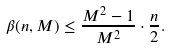Convert formula to latex. <formula><loc_0><loc_0><loc_500><loc_500>\beta ( n , M ) \leq \frac { M ^ { 2 } - 1 } { M ^ { 2 } } \cdot \frac { n } { 2 } .</formula> 